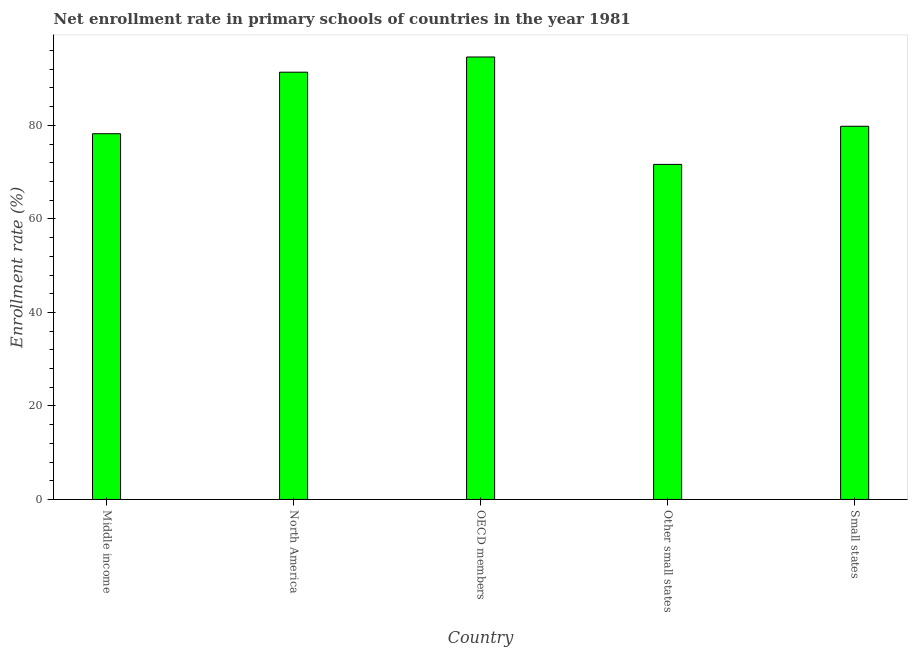Does the graph contain any zero values?
Offer a terse response. No. Does the graph contain grids?
Your answer should be compact. No. What is the title of the graph?
Give a very brief answer. Net enrollment rate in primary schools of countries in the year 1981. What is the label or title of the X-axis?
Ensure brevity in your answer.  Country. What is the label or title of the Y-axis?
Your answer should be very brief. Enrollment rate (%). What is the net enrollment rate in primary schools in Middle income?
Your answer should be compact. 78.22. Across all countries, what is the maximum net enrollment rate in primary schools?
Your response must be concise. 94.63. Across all countries, what is the minimum net enrollment rate in primary schools?
Make the answer very short. 71.66. In which country was the net enrollment rate in primary schools minimum?
Ensure brevity in your answer.  Other small states. What is the sum of the net enrollment rate in primary schools?
Provide a short and direct response. 415.7. What is the difference between the net enrollment rate in primary schools in OECD members and Other small states?
Offer a very short reply. 22.97. What is the average net enrollment rate in primary schools per country?
Give a very brief answer. 83.14. What is the median net enrollment rate in primary schools?
Keep it short and to the point. 79.82. In how many countries, is the net enrollment rate in primary schools greater than 60 %?
Your answer should be compact. 5. What is the ratio of the net enrollment rate in primary schools in North America to that in Small states?
Offer a terse response. 1.15. Is the net enrollment rate in primary schools in Middle income less than that in Other small states?
Provide a succinct answer. No. What is the difference between the highest and the second highest net enrollment rate in primary schools?
Your response must be concise. 3.25. Is the sum of the net enrollment rate in primary schools in North America and Other small states greater than the maximum net enrollment rate in primary schools across all countries?
Ensure brevity in your answer.  Yes. What is the difference between the highest and the lowest net enrollment rate in primary schools?
Your response must be concise. 22.97. What is the Enrollment rate (%) of Middle income?
Ensure brevity in your answer.  78.22. What is the Enrollment rate (%) of North America?
Provide a short and direct response. 91.38. What is the Enrollment rate (%) of OECD members?
Offer a terse response. 94.63. What is the Enrollment rate (%) in Other small states?
Provide a short and direct response. 71.66. What is the Enrollment rate (%) in Small states?
Give a very brief answer. 79.82. What is the difference between the Enrollment rate (%) in Middle income and North America?
Offer a very short reply. -13.16. What is the difference between the Enrollment rate (%) in Middle income and OECD members?
Give a very brief answer. -16.41. What is the difference between the Enrollment rate (%) in Middle income and Other small states?
Ensure brevity in your answer.  6.56. What is the difference between the Enrollment rate (%) in Middle income and Small states?
Provide a short and direct response. -1.6. What is the difference between the Enrollment rate (%) in North America and OECD members?
Provide a succinct answer. -3.25. What is the difference between the Enrollment rate (%) in North America and Other small states?
Ensure brevity in your answer.  19.72. What is the difference between the Enrollment rate (%) in North America and Small states?
Provide a short and direct response. 11.56. What is the difference between the Enrollment rate (%) in OECD members and Other small states?
Provide a short and direct response. 22.97. What is the difference between the Enrollment rate (%) in OECD members and Small states?
Give a very brief answer. 14.81. What is the difference between the Enrollment rate (%) in Other small states and Small states?
Provide a succinct answer. -8.16. What is the ratio of the Enrollment rate (%) in Middle income to that in North America?
Offer a terse response. 0.86. What is the ratio of the Enrollment rate (%) in Middle income to that in OECD members?
Provide a succinct answer. 0.83. What is the ratio of the Enrollment rate (%) in Middle income to that in Other small states?
Offer a very short reply. 1.09. What is the ratio of the Enrollment rate (%) in Middle income to that in Small states?
Provide a short and direct response. 0.98. What is the ratio of the Enrollment rate (%) in North America to that in Other small states?
Offer a very short reply. 1.27. What is the ratio of the Enrollment rate (%) in North America to that in Small states?
Provide a succinct answer. 1.15. What is the ratio of the Enrollment rate (%) in OECD members to that in Other small states?
Offer a terse response. 1.32. What is the ratio of the Enrollment rate (%) in OECD members to that in Small states?
Provide a succinct answer. 1.19. What is the ratio of the Enrollment rate (%) in Other small states to that in Small states?
Ensure brevity in your answer.  0.9. 